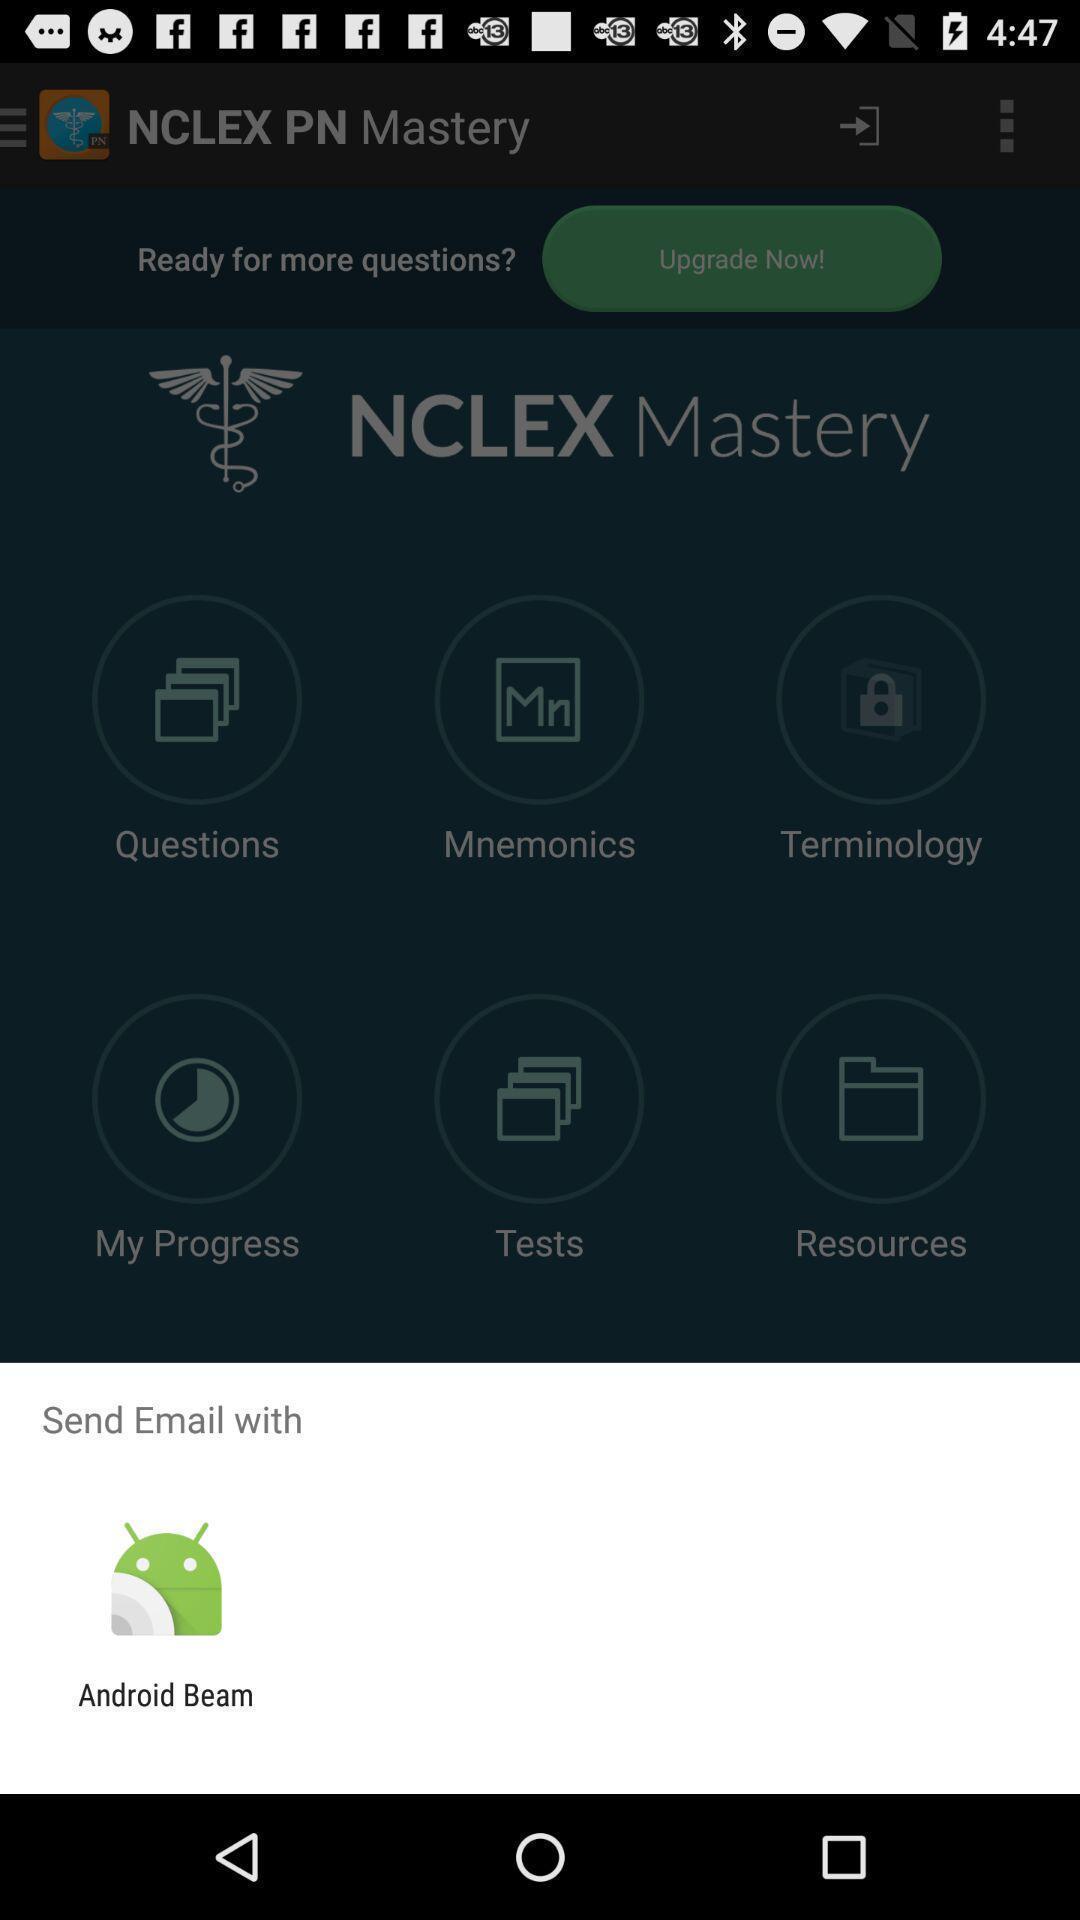Describe the key features of this screenshot. Widget showing one data transferring app. 